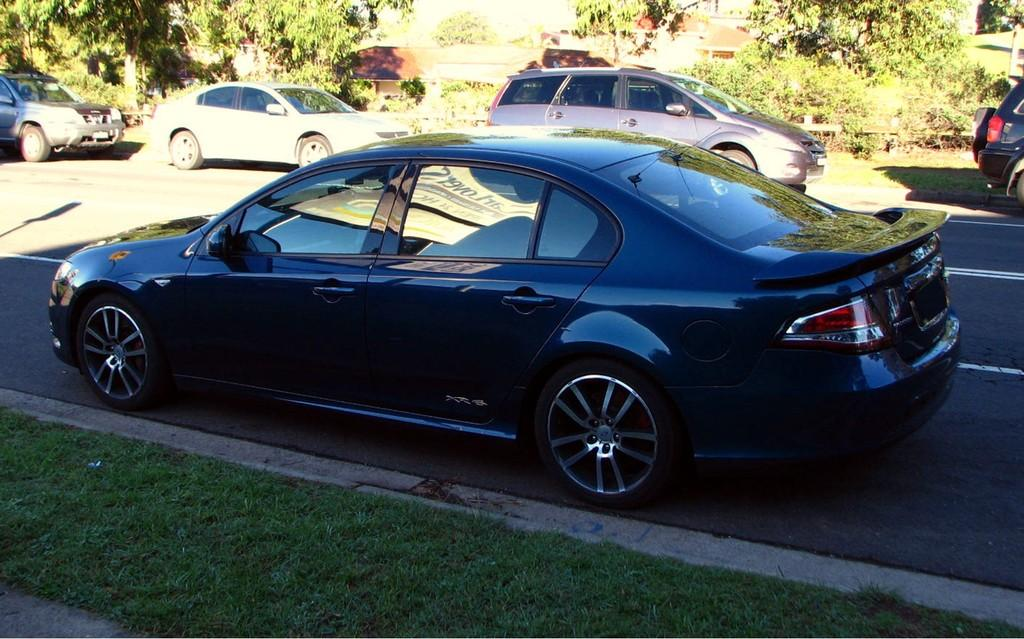What is the main feature of the image? There is a road in the image. What type of vegetation can be seen in the image? There is grass visible in the image. What is happening on the road in the image? There are vehicles on the road. What can be seen in the distance in the image? There are trees and buildings in the background of the image. Are there any fairies flying around the trees in the image? There is no mention of fairies in the image, and therefore no such creatures can be observed. 